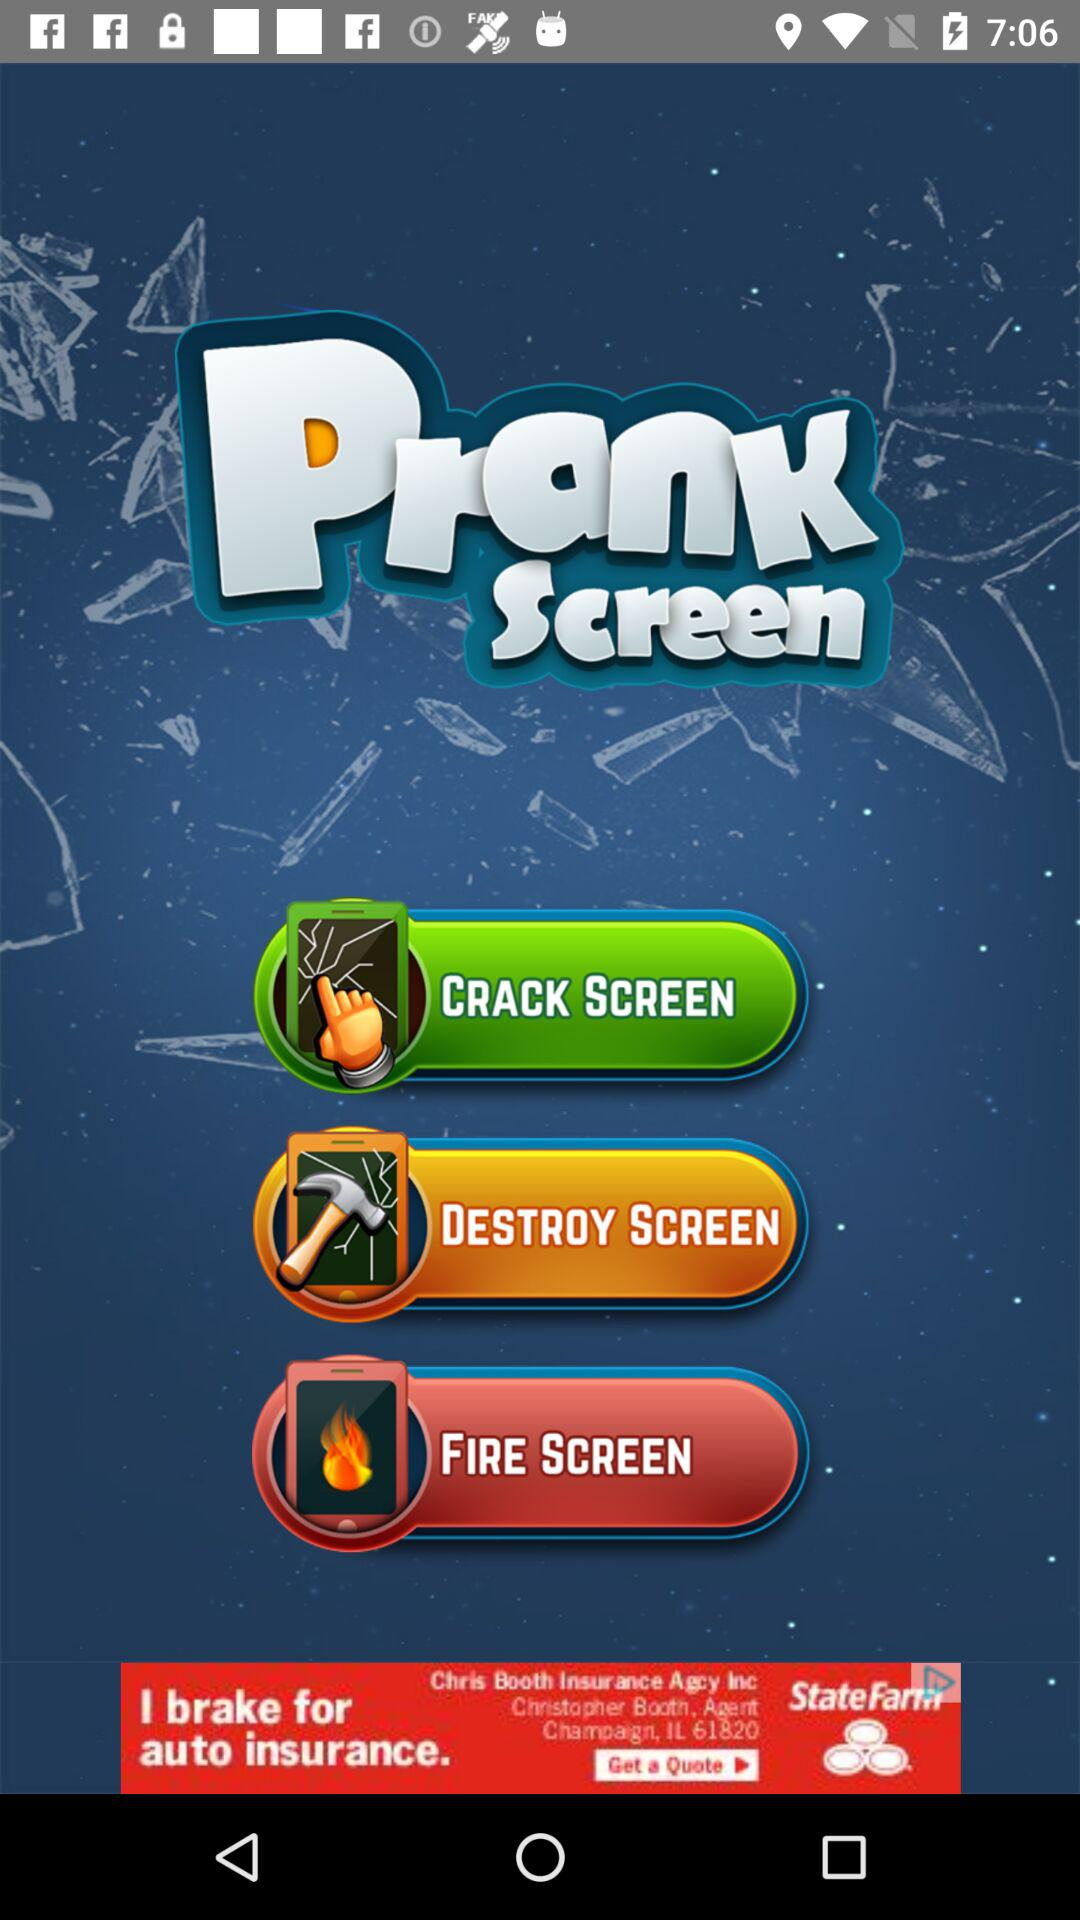What is the application name? The application name is "Prank Screen". 